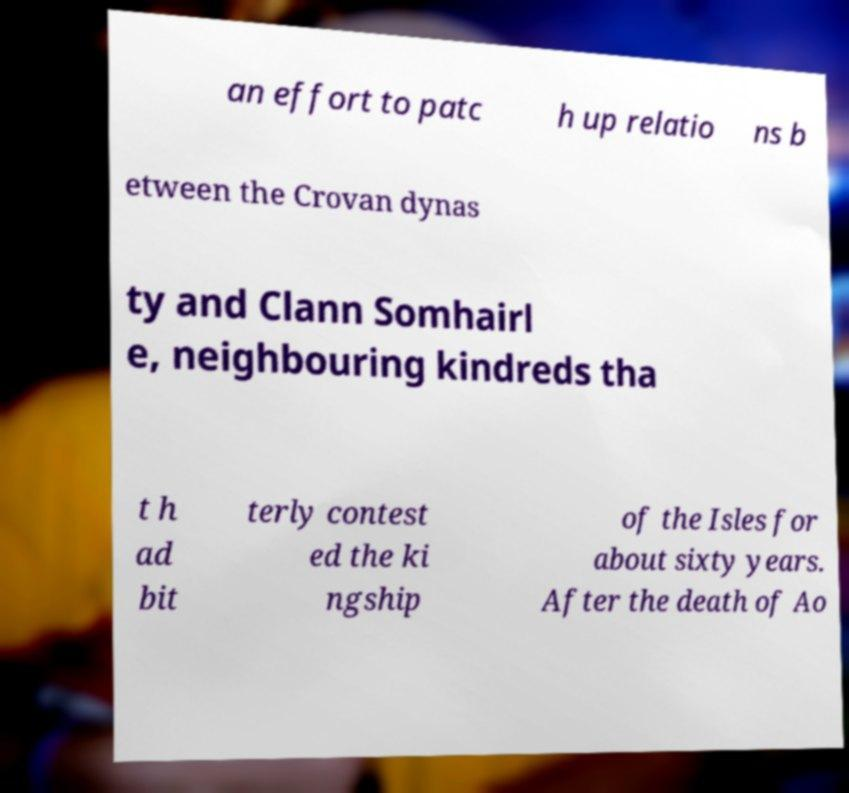Please read and relay the text visible in this image. What does it say? an effort to patc h up relatio ns b etween the Crovan dynas ty and Clann Somhairl e, neighbouring kindreds tha t h ad bit terly contest ed the ki ngship of the Isles for about sixty years. After the death of Ao 